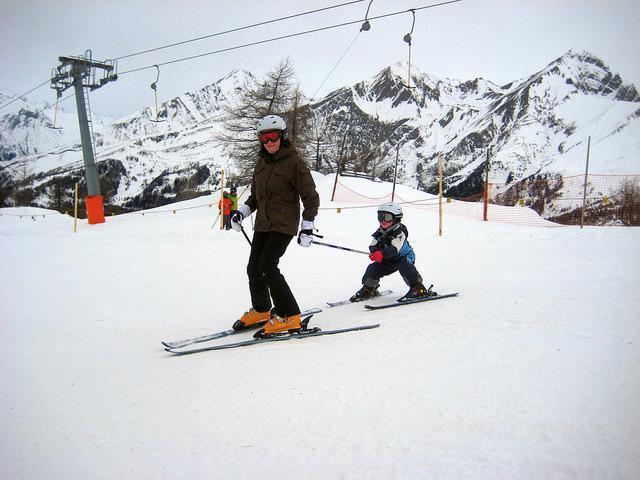How many people can you see?
Give a very brief answer. 2. 